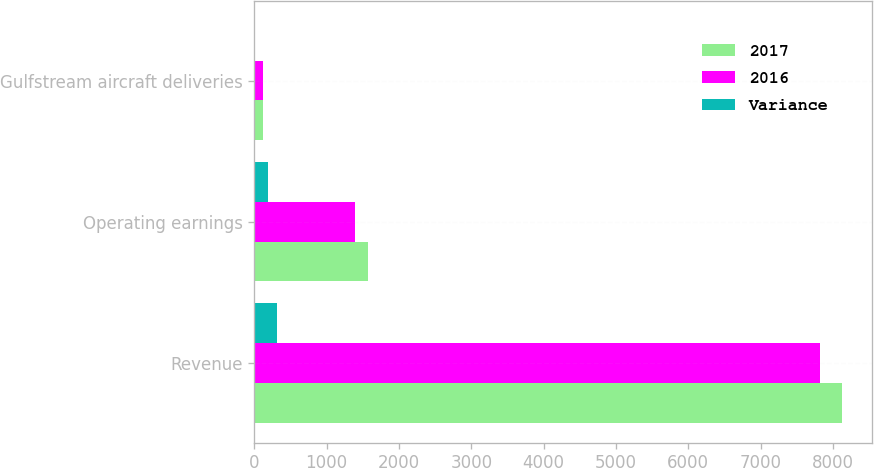<chart> <loc_0><loc_0><loc_500><loc_500><stacked_bar_chart><ecel><fcel>Revenue<fcel>Operating earnings<fcel>Gulfstream aircraft deliveries<nl><fcel>2017<fcel>8129<fcel>1577<fcel>120<nl><fcel>2016<fcel>7815<fcel>1394<fcel>121<nl><fcel>Variance<fcel>314<fcel>183<fcel>1<nl></chart> 